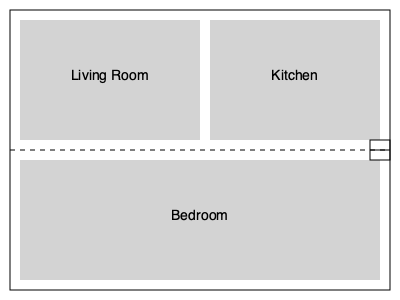Based on the floor plan provided, write a brief scene-setting paragraph that effectively describes the layout of this small apartment. Focus on creating a vivid mental image for the reader while maintaining a clear and concise writing style. To create an effective scene-setting paragraph based on the floor plan, follow these steps:

1. Start with a general overview of the space:
   Describe the apartment as small and compact, with a simple layout.

2. Identify the main areas:
   Mention the three primary rooms - living room, kitchen, and bedroom.

3. Describe the layout:
   Explain how the rooms are arranged in relation to each other. The living room and kitchen are side-by-side on one end, while the bedroom takes up the other half of the apartment.

4. Add sensory details:
   Include details about light, space, and atmosphere to make the description more vivid.

5. Use spatial language:
   Employ words like "adjacent," "across," or "opposite" to clarify the relationships between rooms.

6. Include a unique feature:
   Mention the door at the center of the apartment, which likely serves as the main entrance.

7. Conclude with an overall impression:
   Sum up the feeling of the space, such as its coziness or efficiency.

Here's an example of how this could be written:

"The small apartment was a study in efficient design. Upon entering through the central door, the space unfolded like a book. To the left, a modest living room shared a wall with a compact kitchen, their open plan design creating an illusion of spaciousness. To the right, spanning the entire width of the apartment, lay a simple bedroom. Despite its limited square footage, the clever layout and the natural light streaming through windows in each room gave the apartment a cozy, yet airy feel."

This paragraph effectively describes the layout while creating a vivid mental image for the reader, maintaining a clear and concise writing style suitable for a new author with raw talent but lacking technical skills.
Answer: A concise, vivid description of the apartment's layout, highlighting its efficient design and the relationship between the living room, kitchen, and bedroom, while creating a cozy atmosphere. 